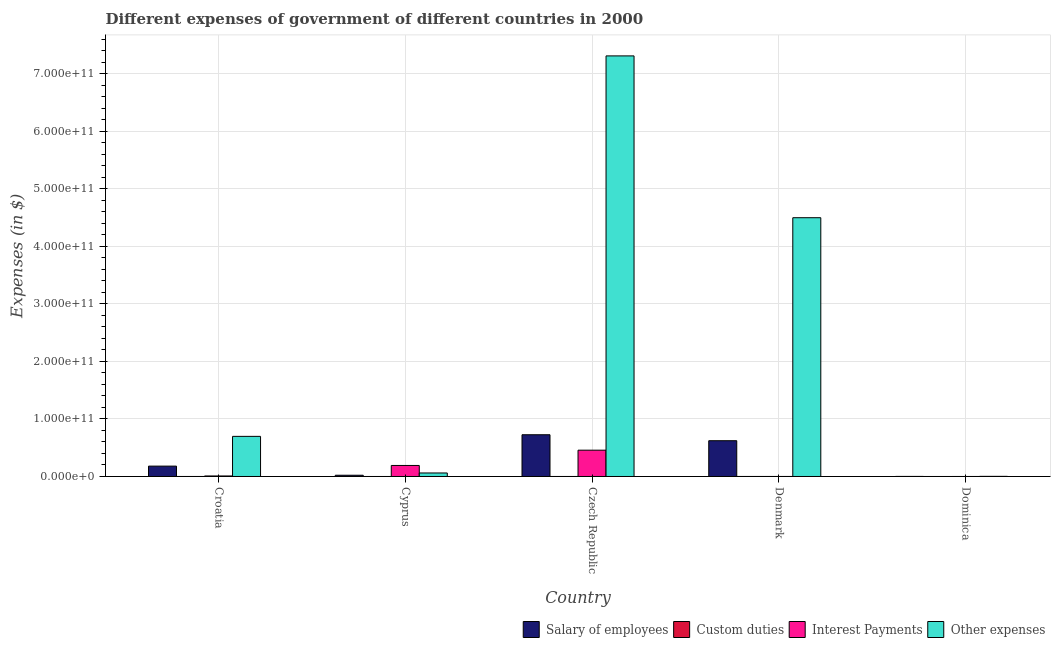How many different coloured bars are there?
Offer a terse response. 4. How many groups of bars are there?
Provide a short and direct response. 5. How many bars are there on the 2nd tick from the right?
Make the answer very short. 4. What is the label of the 5th group of bars from the left?
Your answer should be compact. Dominica. In how many cases, is the number of bars for a given country not equal to the number of legend labels?
Give a very brief answer. 2. What is the amount spent on custom duties in Czech Republic?
Give a very brief answer. 1.90e+07. Across all countries, what is the maximum amount spent on interest payments?
Offer a very short reply. 4.57e+1. Across all countries, what is the minimum amount spent on custom duties?
Give a very brief answer. 0. In which country was the amount spent on interest payments maximum?
Your answer should be compact. Czech Republic. What is the total amount spent on other expenses in the graph?
Your answer should be compact. 1.26e+12. What is the difference between the amount spent on interest payments in Cyprus and that in Czech Republic?
Your answer should be very brief. -2.66e+1. What is the difference between the amount spent on salary of employees in Cyprus and the amount spent on interest payments in Czech Republic?
Make the answer very short. -4.36e+1. What is the average amount spent on salary of employees per country?
Your answer should be very brief. 3.10e+1. What is the difference between the amount spent on salary of employees and amount spent on other expenses in Dominica?
Keep it short and to the point. -1.09e+08. What is the ratio of the amount spent on interest payments in Croatia to that in Dominica?
Your answer should be very brief. 197.23. Is the amount spent on other expenses in Croatia less than that in Cyprus?
Offer a very short reply. No. Is the difference between the amount spent on salary of employees in Croatia and Czech Republic greater than the difference between the amount spent on custom duties in Croatia and Czech Republic?
Make the answer very short. No. What is the difference between the highest and the second highest amount spent on custom duties?
Offer a terse response. 2.50e+07. What is the difference between the highest and the lowest amount spent on salary of employees?
Your response must be concise. 7.24e+1. In how many countries, is the amount spent on interest payments greater than the average amount spent on interest payments taken over all countries?
Keep it short and to the point. 2. Is the sum of the amount spent on interest payments in Cyprus and Czech Republic greater than the maximum amount spent on salary of employees across all countries?
Keep it short and to the point. No. How many countries are there in the graph?
Ensure brevity in your answer.  5. What is the difference between two consecutive major ticks on the Y-axis?
Your answer should be compact. 1.00e+11. Are the values on the major ticks of Y-axis written in scientific E-notation?
Your answer should be compact. Yes. Does the graph contain any zero values?
Keep it short and to the point. Yes. How many legend labels are there?
Offer a terse response. 4. How are the legend labels stacked?
Make the answer very short. Horizontal. What is the title of the graph?
Give a very brief answer. Different expenses of government of different countries in 2000. Does "Primary education" appear as one of the legend labels in the graph?
Offer a very short reply. No. What is the label or title of the Y-axis?
Ensure brevity in your answer.  Expenses (in $). What is the Expenses (in $) of Salary of employees in Croatia?
Provide a short and direct response. 1.80e+1. What is the Expenses (in $) in Custom duties in Croatia?
Ensure brevity in your answer.  2.26e+06. What is the Expenses (in $) in Interest Payments in Croatia?
Offer a very short reply. 9.07e+08. What is the Expenses (in $) of Other expenses in Croatia?
Offer a terse response. 6.97e+1. What is the Expenses (in $) in Salary of employees in Cyprus?
Keep it short and to the point. 2.17e+09. What is the Expenses (in $) of Custom duties in Cyprus?
Offer a very short reply. 0. What is the Expenses (in $) in Interest Payments in Cyprus?
Your answer should be compact. 1.92e+1. What is the Expenses (in $) in Other expenses in Cyprus?
Give a very brief answer. 6.10e+09. What is the Expenses (in $) in Salary of employees in Czech Republic?
Your answer should be very brief. 7.26e+1. What is the Expenses (in $) of Custom duties in Czech Republic?
Your answer should be compact. 1.90e+07. What is the Expenses (in $) of Interest Payments in Czech Republic?
Make the answer very short. 4.57e+1. What is the Expenses (in $) in Other expenses in Czech Republic?
Your response must be concise. 7.31e+11. What is the Expenses (in $) in Salary of employees in Denmark?
Provide a short and direct response. 6.22e+1. What is the Expenses (in $) in Custom duties in Denmark?
Provide a short and direct response. 4.40e+07. What is the Expenses (in $) of Interest Payments in Denmark?
Your response must be concise. 4.25e+07. What is the Expenses (in $) of Other expenses in Denmark?
Your response must be concise. 4.50e+11. What is the Expenses (in $) in Salary of employees in Dominica?
Your answer should be compact. 1.21e+08. What is the Expenses (in $) in Interest Payments in Dominica?
Provide a short and direct response. 4.60e+06. What is the Expenses (in $) of Other expenses in Dominica?
Offer a very short reply. 2.30e+08. Across all countries, what is the maximum Expenses (in $) of Salary of employees?
Your response must be concise. 7.26e+1. Across all countries, what is the maximum Expenses (in $) in Custom duties?
Provide a short and direct response. 4.40e+07. Across all countries, what is the maximum Expenses (in $) in Interest Payments?
Your response must be concise. 4.57e+1. Across all countries, what is the maximum Expenses (in $) of Other expenses?
Provide a succinct answer. 7.31e+11. Across all countries, what is the minimum Expenses (in $) in Salary of employees?
Your answer should be very brief. 1.21e+08. Across all countries, what is the minimum Expenses (in $) in Interest Payments?
Give a very brief answer. 4.60e+06. Across all countries, what is the minimum Expenses (in $) of Other expenses?
Make the answer very short. 2.30e+08. What is the total Expenses (in $) in Salary of employees in the graph?
Offer a very short reply. 1.55e+11. What is the total Expenses (in $) of Custom duties in the graph?
Your answer should be compact. 6.53e+07. What is the total Expenses (in $) in Interest Payments in the graph?
Your response must be concise. 6.58e+1. What is the total Expenses (in $) in Other expenses in the graph?
Offer a terse response. 1.26e+12. What is the difference between the Expenses (in $) in Salary of employees in Croatia and that in Cyprus?
Provide a succinct answer. 1.58e+1. What is the difference between the Expenses (in $) in Interest Payments in Croatia and that in Cyprus?
Offer a very short reply. -1.82e+1. What is the difference between the Expenses (in $) of Other expenses in Croatia and that in Cyprus?
Ensure brevity in your answer.  6.36e+1. What is the difference between the Expenses (in $) in Salary of employees in Croatia and that in Czech Republic?
Offer a terse response. -5.45e+1. What is the difference between the Expenses (in $) in Custom duties in Croatia and that in Czech Republic?
Keep it short and to the point. -1.67e+07. What is the difference between the Expenses (in $) of Interest Payments in Croatia and that in Czech Republic?
Make the answer very short. -4.48e+1. What is the difference between the Expenses (in $) of Other expenses in Croatia and that in Czech Republic?
Your response must be concise. -6.61e+11. What is the difference between the Expenses (in $) of Salary of employees in Croatia and that in Denmark?
Provide a short and direct response. -4.42e+1. What is the difference between the Expenses (in $) in Custom duties in Croatia and that in Denmark?
Offer a terse response. -4.17e+07. What is the difference between the Expenses (in $) in Interest Payments in Croatia and that in Denmark?
Offer a very short reply. 8.65e+08. What is the difference between the Expenses (in $) of Other expenses in Croatia and that in Denmark?
Your answer should be compact. -3.80e+11. What is the difference between the Expenses (in $) in Salary of employees in Croatia and that in Dominica?
Your answer should be compact. 1.79e+1. What is the difference between the Expenses (in $) in Interest Payments in Croatia and that in Dominica?
Give a very brief answer. 9.03e+08. What is the difference between the Expenses (in $) in Other expenses in Croatia and that in Dominica?
Keep it short and to the point. 6.95e+1. What is the difference between the Expenses (in $) of Salary of employees in Cyprus and that in Czech Republic?
Ensure brevity in your answer.  -7.04e+1. What is the difference between the Expenses (in $) of Interest Payments in Cyprus and that in Czech Republic?
Your answer should be compact. -2.66e+1. What is the difference between the Expenses (in $) of Other expenses in Cyprus and that in Czech Republic?
Your answer should be compact. -7.25e+11. What is the difference between the Expenses (in $) of Salary of employees in Cyprus and that in Denmark?
Provide a succinct answer. -6.00e+1. What is the difference between the Expenses (in $) of Interest Payments in Cyprus and that in Denmark?
Your response must be concise. 1.91e+1. What is the difference between the Expenses (in $) of Other expenses in Cyprus and that in Denmark?
Offer a very short reply. -4.44e+11. What is the difference between the Expenses (in $) of Salary of employees in Cyprus and that in Dominica?
Provide a succinct answer. 2.05e+09. What is the difference between the Expenses (in $) in Interest Payments in Cyprus and that in Dominica?
Keep it short and to the point. 1.91e+1. What is the difference between the Expenses (in $) of Other expenses in Cyprus and that in Dominica?
Provide a short and direct response. 5.87e+09. What is the difference between the Expenses (in $) in Salary of employees in Czech Republic and that in Denmark?
Your answer should be compact. 1.04e+1. What is the difference between the Expenses (in $) of Custom duties in Czech Republic and that in Denmark?
Provide a succinct answer. -2.50e+07. What is the difference between the Expenses (in $) of Interest Payments in Czech Republic and that in Denmark?
Keep it short and to the point. 4.57e+1. What is the difference between the Expenses (in $) of Other expenses in Czech Republic and that in Denmark?
Your answer should be very brief. 2.81e+11. What is the difference between the Expenses (in $) of Salary of employees in Czech Republic and that in Dominica?
Your answer should be very brief. 7.24e+1. What is the difference between the Expenses (in $) of Interest Payments in Czech Republic and that in Dominica?
Give a very brief answer. 4.57e+1. What is the difference between the Expenses (in $) in Other expenses in Czech Republic and that in Dominica?
Provide a succinct answer. 7.31e+11. What is the difference between the Expenses (in $) in Salary of employees in Denmark and that in Dominica?
Provide a succinct answer. 6.21e+1. What is the difference between the Expenses (in $) of Interest Payments in Denmark and that in Dominica?
Your response must be concise. 3.79e+07. What is the difference between the Expenses (in $) of Other expenses in Denmark and that in Dominica?
Your response must be concise. 4.50e+11. What is the difference between the Expenses (in $) in Salary of employees in Croatia and the Expenses (in $) in Interest Payments in Cyprus?
Your response must be concise. -1.14e+09. What is the difference between the Expenses (in $) in Salary of employees in Croatia and the Expenses (in $) in Other expenses in Cyprus?
Your answer should be compact. 1.19e+1. What is the difference between the Expenses (in $) of Custom duties in Croatia and the Expenses (in $) of Interest Payments in Cyprus?
Your answer should be very brief. -1.91e+1. What is the difference between the Expenses (in $) in Custom duties in Croatia and the Expenses (in $) in Other expenses in Cyprus?
Offer a terse response. -6.10e+09. What is the difference between the Expenses (in $) in Interest Payments in Croatia and the Expenses (in $) in Other expenses in Cyprus?
Provide a short and direct response. -5.19e+09. What is the difference between the Expenses (in $) in Salary of employees in Croatia and the Expenses (in $) in Custom duties in Czech Republic?
Give a very brief answer. 1.80e+1. What is the difference between the Expenses (in $) in Salary of employees in Croatia and the Expenses (in $) in Interest Payments in Czech Republic?
Offer a very short reply. -2.77e+1. What is the difference between the Expenses (in $) of Salary of employees in Croatia and the Expenses (in $) of Other expenses in Czech Republic?
Make the answer very short. -7.13e+11. What is the difference between the Expenses (in $) of Custom duties in Croatia and the Expenses (in $) of Interest Payments in Czech Republic?
Offer a very short reply. -4.57e+1. What is the difference between the Expenses (in $) of Custom duties in Croatia and the Expenses (in $) of Other expenses in Czech Republic?
Keep it short and to the point. -7.31e+11. What is the difference between the Expenses (in $) in Interest Payments in Croatia and the Expenses (in $) in Other expenses in Czech Republic?
Your answer should be compact. -7.30e+11. What is the difference between the Expenses (in $) in Salary of employees in Croatia and the Expenses (in $) in Custom duties in Denmark?
Provide a succinct answer. 1.80e+1. What is the difference between the Expenses (in $) of Salary of employees in Croatia and the Expenses (in $) of Interest Payments in Denmark?
Provide a succinct answer. 1.80e+1. What is the difference between the Expenses (in $) in Salary of employees in Croatia and the Expenses (in $) in Other expenses in Denmark?
Your answer should be compact. -4.32e+11. What is the difference between the Expenses (in $) in Custom duties in Croatia and the Expenses (in $) in Interest Payments in Denmark?
Make the answer very short. -4.02e+07. What is the difference between the Expenses (in $) in Custom duties in Croatia and the Expenses (in $) in Other expenses in Denmark?
Your response must be concise. -4.50e+11. What is the difference between the Expenses (in $) of Interest Payments in Croatia and the Expenses (in $) of Other expenses in Denmark?
Your answer should be compact. -4.49e+11. What is the difference between the Expenses (in $) in Salary of employees in Croatia and the Expenses (in $) in Interest Payments in Dominica?
Provide a short and direct response. 1.80e+1. What is the difference between the Expenses (in $) of Salary of employees in Croatia and the Expenses (in $) of Other expenses in Dominica?
Your answer should be compact. 1.78e+1. What is the difference between the Expenses (in $) of Custom duties in Croatia and the Expenses (in $) of Interest Payments in Dominica?
Offer a very short reply. -2.34e+06. What is the difference between the Expenses (in $) in Custom duties in Croatia and the Expenses (in $) in Other expenses in Dominica?
Ensure brevity in your answer.  -2.28e+08. What is the difference between the Expenses (in $) in Interest Payments in Croatia and the Expenses (in $) in Other expenses in Dominica?
Offer a very short reply. 6.77e+08. What is the difference between the Expenses (in $) of Salary of employees in Cyprus and the Expenses (in $) of Custom duties in Czech Republic?
Your response must be concise. 2.15e+09. What is the difference between the Expenses (in $) in Salary of employees in Cyprus and the Expenses (in $) in Interest Payments in Czech Republic?
Ensure brevity in your answer.  -4.36e+1. What is the difference between the Expenses (in $) in Salary of employees in Cyprus and the Expenses (in $) in Other expenses in Czech Republic?
Ensure brevity in your answer.  -7.29e+11. What is the difference between the Expenses (in $) of Interest Payments in Cyprus and the Expenses (in $) of Other expenses in Czech Republic?
Offer a terse response. -7.12e+11. What is the difference between the Expenses (in $) of Salary of employees in Cyprus and the Expenses (in $) of Custom duties in Denmark?
Give a very brief answer. 2.12e+09. What is the difference between the Expenses (in $) in Salary of employees in Cyprus and the Expenses (in $) in Interest Payments in Denmark?
Keep it short and to the point. 2.13e+09. What is the difference between the Expenses (in $) of Salary of employees in Cyprus and the Expenses (in $) of Other expenses in Denmark?
Your answer should be compact. -4.48e+11. What is the difference between the Expenses (in $) of Interest Payments in Cyprus and the Expenses (in $) of Other expenses in Denmark?
Offer a very short reply. -4.31e+11. What is the difference between the Expenses (in $) of Salary of employees in Cyprus and the Expenses (in $) of Interest Payments in Dominica?
Make the answer very short. 2.16e+09. What is the difference between the Expenses (in $) in Salary of employees in Cyprus and the Expenses (in $) in Other expenses in Dominica?
Provide a succinct answer. 1.94e+09. What is the difference between the Expenses (in $) in Interest Payments in Cyprus and the Expenses (in $) in Other expenses in Dominica?
Provide a succinct answer. 1.89e+1. What is the difference between the Expenses (in $) of Salary of employees in Czech Republic and the Expenses (in $) of Custom duties in Denmark?
Provide a succinct answer. 7.25e+1. What is the difference between the Expenses (in $) in Salary of employees in Czech Republic and the Expenses (in $) in Interest Payments in Denmark?
Give a very brief answer. 7.25e+1. What is the difference between the Expenses (in $) in Salary of employees in Czech Republic and the Expenses (in $) in Other expenses in Denmark?
Your answer should be very brief. -3.77e+11. What is the difference between the Expenses (in $) in Custom duties in Czech Republic and the Expenses (in $) in Interest Payments in Denmark?
Provide a succinct answer. -2.35e+07. What is the difference between the Expenses (in $) in Custom duties in Czech Republic and the Expenses (in $) in Other expenses in Denmark?
Offer a very short reply. -4.50e+11. What is the difference between the Expenses (in $) of Interest Payments in Czech Republic and the Expenses (in $) of Other expenses in Denmark?
Provide a short and direct response. -4.04e+11. What is the difference between the Expenses (in $) in Salary of employees in Czech Republic and the Expenses (in $) in Interest Payments in Dominica?
Your answer should be very brief. 7.26e+1. What is the difference between the Expenses (in $) of Salary of employees in Czech Republic and the Expenses (in $) of Other expenses in Dominica?
Provide a succinct answer. 7.23e+1. What is the difference between the Expenses (in $) in Custom duties in Czech Republic and the Expenses (in $) in Interest Payments in Dominica?
Your response must be concise. 1.44e+07. What is the difference between the Expenses (in $) in Custom duties in Czech Republic and the Expenses (in $) in Other expenses in Dominica?
Keep it short and to the point. -2.11e+08. What is the difference between the Expenses (in $) in Interest Payments in Czech Republic and the Expenses (in $) in Other expenses in Dominica?
Keep it short and to the point. 4.55e+1. What is the difference between the Expenses (in $) of Salary of employees in Denmark and the Expenses (in $) of Interest Payments in Dominica?
Offer a very short reply. 6.22e+1. What is the difference between the Expenses (in $) in Salary of employees in Denmark and the Expenses (in $) in Other expenses in Dominica?
Offer a terse response. 6.20e+1. What is the difference between the Expenses (in $) in Custom duties in Denmark and the Expenses (in $) in Interest Payments in Dominica?
Offer a terse response. 3.94e+07. What is the difference between the Expenses (in $) of Custom duties in Denmark and the Expenses (in $) of Other expenses in Dominica?
Offer a terse response. -1.86e+08. What is the difference between the Expenses (in $) of Interest Payments in Denmark and the Expenses (in $) of Other expenses in Dominica?
Your answer should be compact. -1.88e+08. What is the average Expenses (in $) in Salary of employees per country?
Provide a succinct answer. 3.10e+1. What is the average Expenses (in $) in Custom duties per country?
Offer a terse response. 1.31e+07. What is the average Expenses (in $) of Interest Payments per country?
Provide a succinct answer. 1.32e+1. What is the average Expenses (in $) of Other expenses per country?
Provide a short and direct response. 2.51e+11. What is the difference between the Expenses (in $) of Salary of employees and Expenses (in $) of Custom duties in Croatia?
Offer a very short reply. 1.80e+1. What is the difference between the Expenses (in $) of Salary of employees and Expenses (in $) of Interest Payments in Croatia?
Provide a short and direct response. 1.71e+1. What is the difference between the Expenses (in $) in Salary of employees and Expenses (in $) in Other expenses in Croatia?
Offer a very short reply. -5.17e+1. What is the difference between the Expenses (in $) of Custom duties and Expenses (in $) of Interest Payments in Croatia?
Keep it short and to the point. -9.05e+08. What is the difference between the Expenses (in $) in Custom duties and Expenses (in $) in Other expenses in Croatia?
Offer a terse response. -6.97e+1. What is the difference between the Expenses (in $) in Interest Payments and Expenses (in $) in Other expenses in Croatia?
Give a very brief answer. -6.88e+1. What is the difference between the Expenses (in $) in Salary of employees and Expenses (in $) in Interest Payments in Cyprus?
Your response must be concise. -1.70e+1. What is the difference between the Expenses (in $) of Salary of employees and Expenses (in $) of Other expenses in Cyprus?
Ensure brevity in your answer.  -3.93e+09. What is the difference between the Expenses (in $) in Interest Payments and Expenses (in $) in Other expenses in Cyprus?
Your answer should be compact. 1.31e+1. What is the difference between the Expenses (in $) of Salary of employees and Expenses (in $) of Custom duties in Czech Republic?
Your answer should be very brief. 7.25e+1. What is the difference between the Expenses (in $) in Salary of employees and Expenses (in $) in Interest Payments in Czech Republic?
Give a very brief answer. 2.68e+1. What is the difference between the Expenses (in $) of Salary of employees and Expenses (in $) of Other expenses in Czech Republic?
Give a very brief answer. -6.59e+11. What is the difference between the Expenses (in $) of Custom duties and Expenses (in $) of Interest Payments in Czech Republic?
Offer a terse response. -4.57e+1. What is the difference between the Expenses (in $) in Custom duties and Expenses (in $) in Other expenses in Czech Republic?
Your answer should be very brief. -7.31e+11. What is the difference between the Expenses (in $) of Interest Payments and Expenses (in $) of Other expenses in Czech Republic?
Provide a short and direct response. -6.85e+11. What is the difference between the Expenses (in $) of Salary of employees and Expenses (in $) of Custom duties in Denmark?
Ensure brevity in your answer.  6.21e+1. What is the difference between the Expenses (in $) in Salary of employees and Expenses (in $) in Interest Payments in Denmark?
Your response must be concise. 6.21e+1. What is the difference between the Expenses (in $) of Salary of employees and Expenses (in $) of Other expenses in Denmark?
Provide a succinct answer. -3.88e+11. What is the difference between the Expenses (in $) in Custom duties and Expenses (in $) in Interest Payments in Denmark?
Provide a succinct answer. 1.50e+06. What is the difference between the Expenses (in $) of Custom duties and Expenses (in $) of Other expenses in Denmark?
Make the answer very short. -4.50e+11. What is the difference between the Expenses (in $) of Interest Payments and Expenses (in $) of Other expenses in Denmark?
Your answer should be very brief. -4.50e+11. What is the difference between the Expenses (in $) in Salary of employees and Expenses (in $) in Interest Payments in Dominica?
Keep it short and to the point. 1.16e+08. What is the difference between the Expenses (in $) in Salary of employees and Expenses (in $) in Other expenses in Dominica?
Offer a terse response. -1.09e+08. What is the difference between the Expenses (in $) in Interest Payments and Expenses (in $) in Other expenses in Dominica?
Make the answer very short. -2.26e+08. What is the ratio of the Expenses (in $) in Salary of employees in Croatia to that in Cyprus?
Give a very brief answer. 8.31. What is the ratio of the Expenses (in $) of Interest Payments in Croatia to that in Cyprus?
Offer a terse response. 0.05. What is the ratio of the Expenses (in $) in Other expenses in Croatia to that in Cyprus?
Offer a terse response. 11.43. What is the ratio of the Expenses (in $) of Salary of employees in Croatia to that in Czech Republic?
Provide a succinct answer. 0.25. What is the ratio of the Expenses (in $) in Custom duties in Croatia to that in Czech Republic?
Provide a short and direct response. 0.12. What is the ratio of the Expenses (in $) of Interest Payments in Croatia to that in Czech Republic?
Your answer should be compact. 0.02. What is the ratio of the Expenses (in $) in Other expenses in Croatia to that in Czech Republic?
Offer a terse response. 0.1. What is the ratio of the Expenses (in $) in Salary of employees in Croatia to that in Denmark?
Ensure brevity in your answer.  0.29. What is the ratio of the Expenses (in $) in Custom duties in Croatia to that in Denmark?
Your response must be concise. 0.05. What is the ratio of the Expenses (in $) in Interest Payments in Croatia to that in Denmark?
Provide a succinct answer. 21.35. What is the ratio of the Expenses (in $) of Other expenses in Croatia to that in Denmark?
Provide a short and direct response. 0.15. What is the ratio of the Expenses (in $) of Salary of employees in Croatia to that in Dominica?
Your response must be concise. 148.71. What is the ratio of the Expenses (in $) of Interest Payments in Croatia to that in Dominica?
Make the answer very short. 197.23. What is the ratio of the Expenses (in $) in Other expenses in Croatia to that in Dominica?
Your response must be concise. 303.01. What is the ratio of the Expenses (in $) of Salary of employees in Cyprus to that in Czech Republic?
Provide a short and direct response. 0.03. What is the ratio of the Expenses (in $) of Interest Payments in Cyprus to that in Czech Republic?
Make the answer very short. 0.42. What is the ratio of the Expenses (in $) in Other expenses in Cyprus to that in Czech Republic?
Keep it short and to the point. 0.01. What is the ratio of the Expenses (in $) of Salary of employees in Cyprus to that in Denmark?
Give a very brief answer. 0.03. What is the ratio of the Expenses (in $) of Interest Payments in Cyprus to that in Denmark?
Provide a succinct answer. 450.64. What is the ratio of the Expenses (in $) of Other expenses in Cyprus to that in Denmark?
Your answer should be very brief. 0.01. What is the ratio of the Expenses (in $) of Salary of employees in Cyprus to that in Dominica?
Your response must be concise. 17.9. What is the ratio of the Expenses (in $) in Interest Payments in Cyprus to that in Dominica?
Give a very brief answer. 4163.48. What is the ratio of the Expenses (in $) of Other expenses in Cyprus to that in Dominica?
Keep it short and to the point. 26.51. What is the ratio of the Expenses (in $) in Salary of employees in Czech Republic to that in Denmark?
Give a very brief answer. 1.17. What is the ratio of the Expenses (in $) in Custom duties in Czech Republic to that in Denmark?
Give a very brief answer. 0.43. What is the ratio of the Expenses (in $) of Interest Payments in Czech Republic to that in Denmark?
Offer a very short reply. 1075.91. What is the ratio of the Expenses (in $) in Other expenses in Czech Republic to that in Denmark?
Keep it short and to the point. 1.63. What is the ratio of the Expenses (in $) of Salary of employees in Czech Republic to that in Dominica?
Make the answer very short. 599.13. What is the ratio of the Expenses (in $) in Interest Payments in Czech Republic to that in Dominica?
Provide a short and direct response. 9940.43. What is the ratio of the Expenses (in $) of Other expenses in Czech Republic to that in Dominica?
Make the answer very short. 3177.13. What is the ratio of the Expenses (in $) of Salary of employees in Denmark to that in Dominica?
Provide a short and direct response. 513.48. What is the ratio of the Expenses (in $) in Interest Payments in Denmark to that in Dominica?
Provide a short and direct response. 9.24. What is the ratio of the Expenses (in $) of Other expenses in Denmark to that in Dominica?
Ensure brevity in your answer.  1954.82. What is the difference between the highest and the second highest Expenses (in $) in Salary of employees?
Your answer should be very brief. 1.04e+1. What is the difference between the highest and the second highest Expenses (in $) in Custom duties?
Your response must be concise. 2.50e+07. What is the difference between the highest and the second highest Expenses (in $) of Interest Payments?
Your answer should be compact. 2.66e+1. What is the difference between the highest and the second highest Expenses (in $) of Other expenses?
Provide a short and direct response. 2.81e+11. What is the difference between the highest and the lowest Expenses (in $) of Salary of employees?
Provide a short and direct response. 7.24e+1. What is the difference between the highest and the lowest Expenses (in $) in Custom duties?
Offer a terse response. 4.40e+07. What is the difference between the highest and the lowest Expenses (in $) of Interest Payments?
Give a very brief answer. 4.57e+1. What is the difference between the highest and the lowest Expenses (in $) in Other expenses?
Your response must be concise. 7.31e+11. 